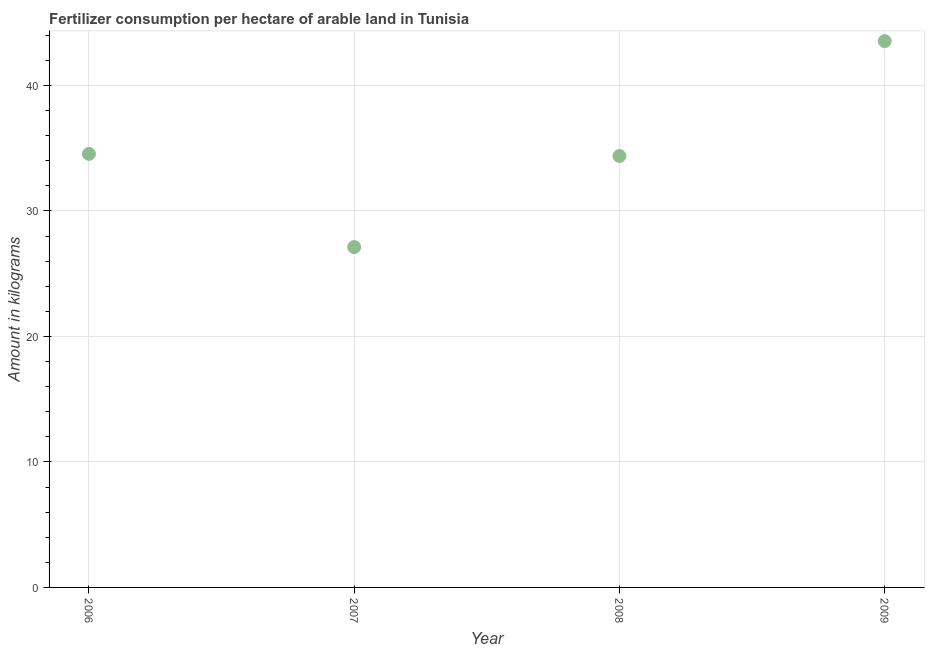What is the amount of fertilizer consumption in 2007?
Give a very brief answer. 27.12. Across all years, what is the maximum amount of fertilizer consumption?
Keep it short and to the point. 43.53. Across all years, what is the minimum amount of fertilizer consumption?
Keep it short and to the point. 27.12. What is the sum of the amount of fertilizer consumption?
Your answer should be very brief. 139.56. What is the difference between the amount of fertilizer consumption in 2007 and 2009?
Your answer should be compact. -16.41. What is the average amount of fertilizer consumption per year?
Provide a succinct answer. 34.89. What is the median amount of fertilizer consumption?
Your answer should be compact. 34.46. What is the ratio of the amount of fertilizer consumption in 2006 to that in 2007?
Give a very brief answer. 1.27. Is the difference between the amount of fertilizer consumption in 2007 and 2008 greater than the difference between any two years?
Give a very brief answer. No. What is the difference between the highest and the second highest amount of fertilizer consumption?
Offer a terse response. 8.99. Is the sum of the amount of fertilizer consumption in 2007 and 2009 greater than the maximum amount of fertilizer consumption across all years?
Make the answer very short. Yes. What is the difference between the highest and the lowest amount of fertilizer consumption?
Provide a short and direct response. 16.41. How many dotlines are there?
Your answer should be compact. 1. What is the difference between two consecutive major ticks on the Y-axis?
Your answer should be compact. 10. Are the values on the major ticks of Y-axis written in scientific E-notation?
Provide a short and direct response. No. Does the graph contain grids?
Offer a very short reply. Yes. What is the title of the graph?
Your answer should be very brief. Fertilizer consumption per hectare of arable land in Tunisia . What is the label or title of the Y-axis?
Keep it short and to the point. Amount in kilograms. What is the Amount in kilograms in 2006?
Your response must be concise. 34.54. What is the Amount in kilograms in 2007?
Give a very brief answer. 27.12. What is the Amount in kilograms in 2008?
Offer a very short reply. 34.38. What is the Amount in kilograms in 2009?
Provide a short and direct response. 43.53. What is the difference between the Amount in kilograms in 2006 and 2007?
Your answer should be compact. 7.43. What is the difference between the Amount in kilograms in 2006 and 2008?
Provide a short and direct response. 0.17. What is the difference between the Amount in kilograms in 2006 and 2009?
Give a very brief answer. -8.98. What is the difference between the Amount in kilograms in 2007 and 2008?
Provide a short and direct response. -7.26. What is the difference between the Amount in kilograms in 2007 and 2009?
Offer a terse response. -16.41. What is the difference between the Amount in kilograms in 2008 and 2009?
Your answer should be compact. -9.15. What is the ratio of the Amount in kilograms in 2006 to that in 2007?
Offer a terse response. 1.27. What is the ratio of the Amount in kilograms in 2006 to that in 2009?
Your answer should be compact. 0.79. What is the ratio of the Amount in kilograms in 2007 to that in 2008?
Give a very brief answer. 0.79. What is the ratio of the Amount in kilograms in 2007 to that in 2009?
Provide a succinct answer. 0.62. What is the ratio of the Amount in kilograms in 2008 to that in 2009?
Give a very brief answer. 0.79. 